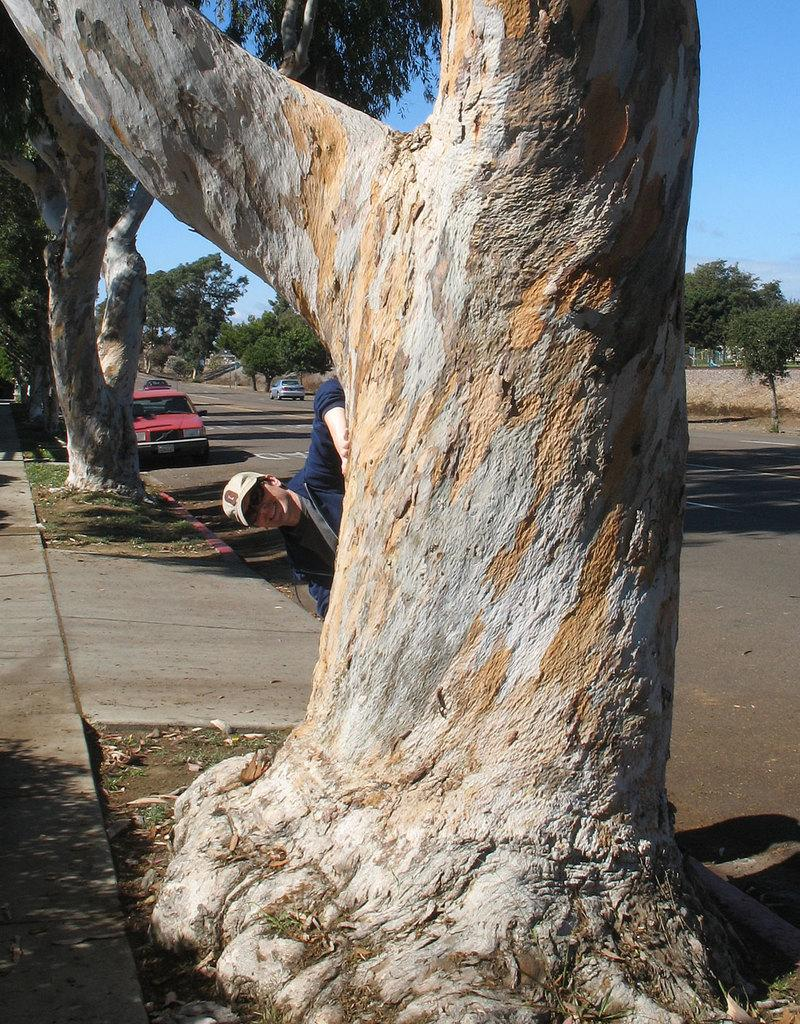What is on the branch in the image? A person is present on the branch. What can be seen on the left side of the image? There is a red color car on the left side of the image. Where is the car located in the image? The car is on the road. How many hands does the owl have in the image? There is no owl present in the image. What is the sound of the engine in the image? There is no engine present in the image, as it is a car and not a vehicle with an engine. 